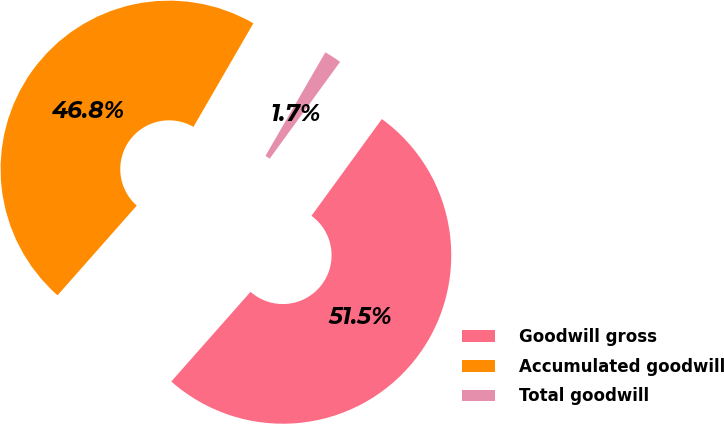Convert chart. <chart><loc_0><loc_0><loc_500><loc_500><pie_chart><fcel>Goodwill gross<fcel>Accumulated goodwill<fcel>Total goodwill<nl><fcel>51.51%<fcel>46.83%<fcel>1.66%<nl></chart> 